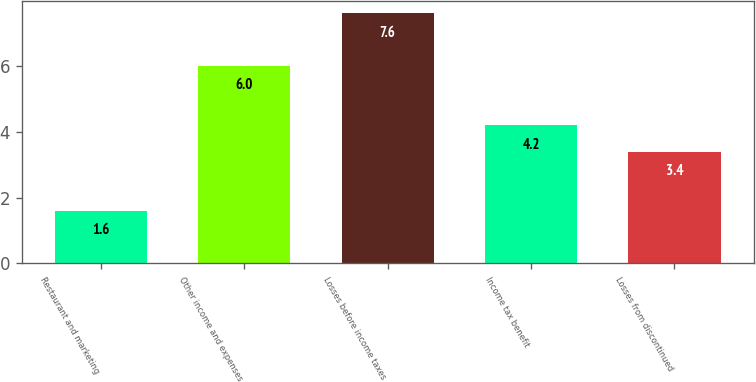<chart> <loc_0><loc_0><loc_500><loc_500><bar_chart><fcel>Restaurant and marketing<fcel>Other income and expenses<fcel>Losses before income taxes<fcel>Income tax benefit<fcel>Losses from discontinued<nl><fcel>1.6<fcel>6<fcel>7.6<fcel>4.2<fcel>3.4<nl></chart> 